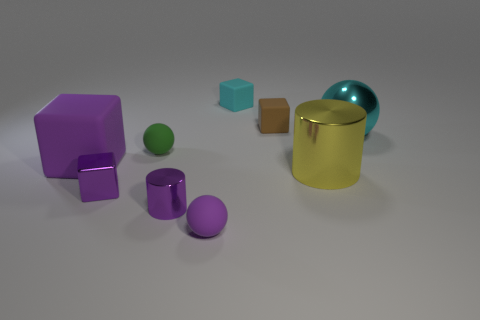Is there a blue cylinder?
Your answer should be compact. No. There is a matte thing that is to the left of the small block that is in front of the green thing that is to the left of the purple cylinder; how big is it?
Give a very brief answer. Large. What number of other objects are the same size as the brown rubber object?
Your answer should be compact. 5. What size is the rubber block that is in front of the cyan ball?
Give a very brief answer. Large. Is there anything else that is the same color as the big matte block?
Make the answer very short. Yes. Are the tiny cube that is to the left of the green object and the big cyan object made of the same material?
Ensure brevity in your answer.  Yes. What number of small rubber balls are both in front of the small purple metallic cube and behind the tiny shiny block?
Ensure brevity in your answer.  0. There is a matte block that is in front of the cyan object on the right side of the tiny cyan thing; what is its size?
Your answer should be very brief. Large. Are there more big rubber things than big green shiny cubes?
Your response must be concise. Yes. There is a object on the right side of the big yellow thing; is it the same color as the tiny rubber cube that is behind the small brown block?
Provide a short and direct response. Yes. 